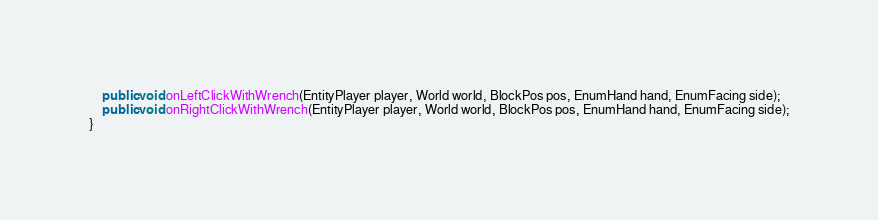<code> <loc_0><loc_0><loc_500><loc_500><_Java_>	public void onLeftClickWithWrench(EntityPlayer player, World world, BlockPos pos, EnumHand hand, EnumFacing side);
	public void onRightClickWithWrench(EntityPlayer player, World world, BlockPos pos, EnumHand hand, EnumFacing side);
}
</code> 